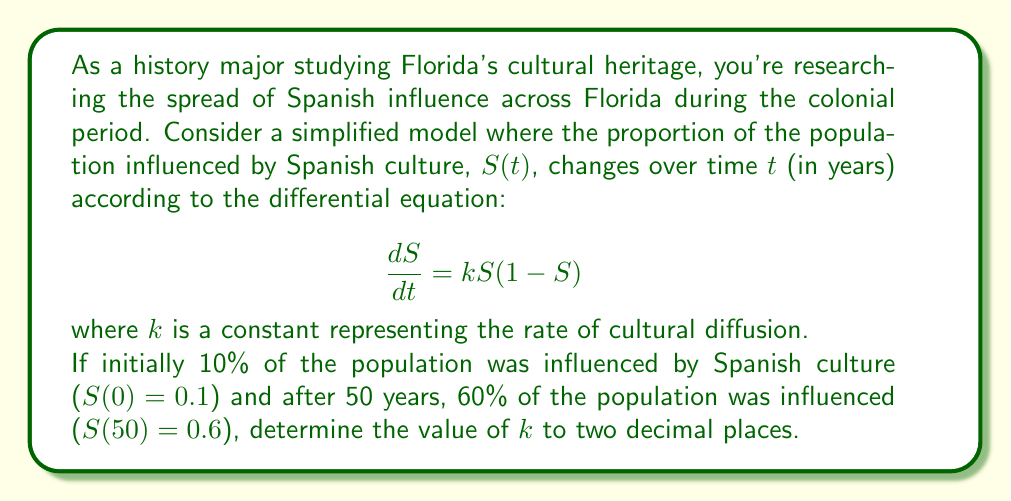Could you help me with this problem? Let's approach this step-by-step:

1) The given differential equation is a logistic growth model:
   $$\frac{dS}{dt} = kS(1-S)$$

2) The solution to this equation is:
   $$S(t) = \frac{1}{1 + Ce^{-kt}}$$
   where $C$ is a constant determined by the initial condition.

3) Using the initial condition $S(0) = 0.1$:
   $$0.1 = \frac{1}{1 + C}$$
   $$C = 9$$

4) Now our solution is:
   $$S(t) = \frac{1}{1 + 9e^{-kt}}$$

5) Using the condition $S(50) = 0.6$:
   $$0.6 = \frac{1}{1 + 9e^{-50k}}$$

6) Solving for $k$:
   $$1 + 9e^{-50k} = \frac{1}{0.6}$$
   $$9e^{-50k} = \frac{1}{0.6} - 1 = \frac{2}{3}$$
   $$e^{-50k} = \frac{2}{27}$$
   $$-50k = \ln(\frac{2}{27})$$
   $$k = -\frac{1}{50}\ln(\frac{2}{27})$$

7) Calculating this value:
   $$k \approx 0.0366$$

8) Rounding to two decimal places:
   $$k \approx 0.04$$
Answer: $k \approx 0.04$ 